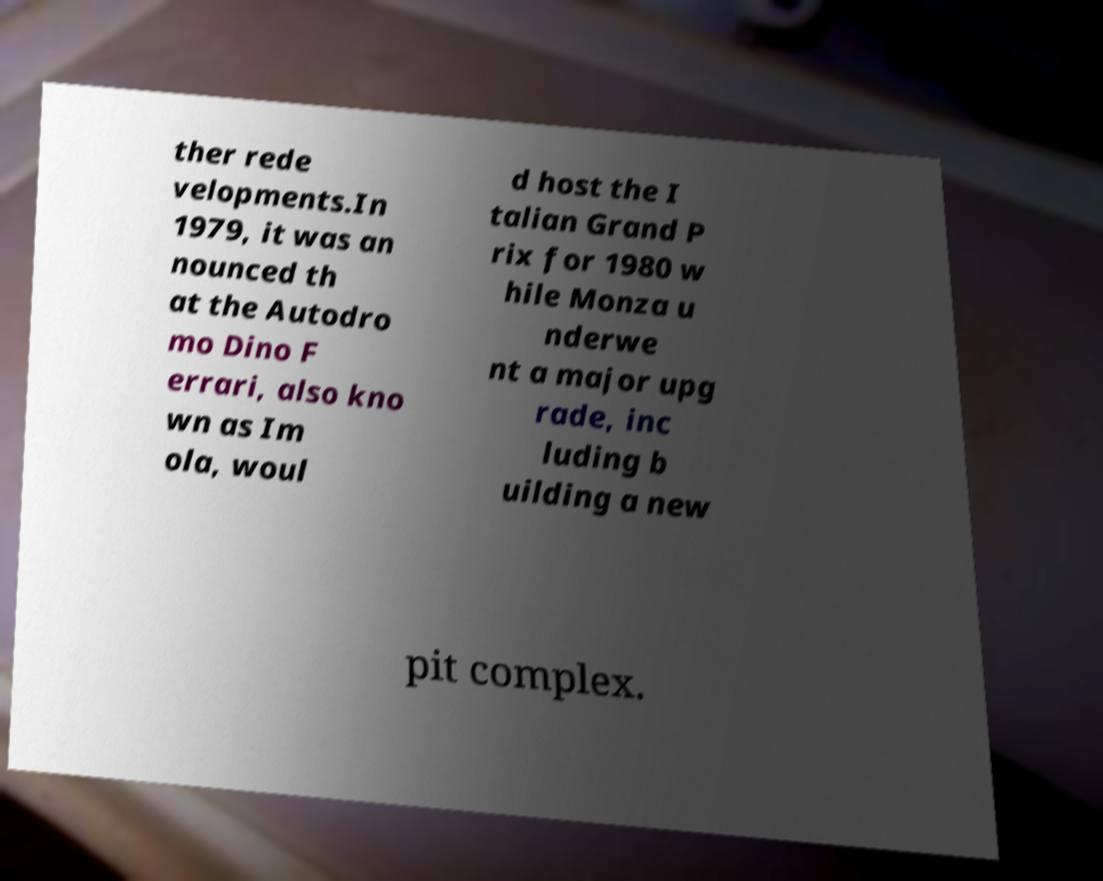Can you read and provide the text displayed in the image?This photo seems to have some interesting text. Can you extract and type it out for me? ther rede velopments.In 1979, it was an nounced th at the Autodro mo Dino F errari, also kno wn as Im ola, woul d host the I talian Grand P rix for 1980 w hile Monza u nderwe nt a major upg rade, inc luding b uilding a new pit complex. 